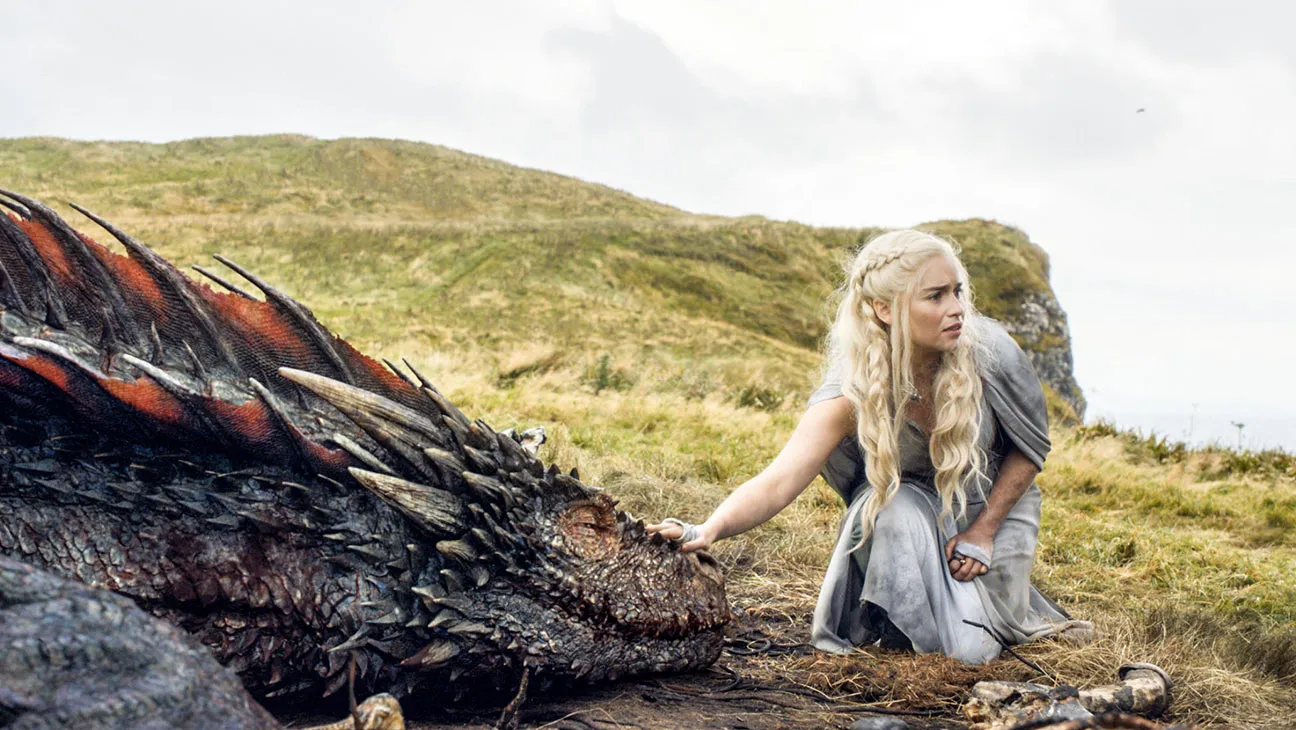How does the color scheme influence the mood of the scene? The color scheme, with its mix of earthy greens, grays, and the vibrant red and black of the dragon, conjures a stark, dramatic contrast. The subdued colors of the landscape and the character’s dress highlight the vividness of the dragon, drawing the viewer’s focus squarely to the mythical creature and symbolizing its importance and power. Meanwhile, the gray overtones contribute to a somber, foreboding atmosphere, possibly foreshadowing future difficulties. 